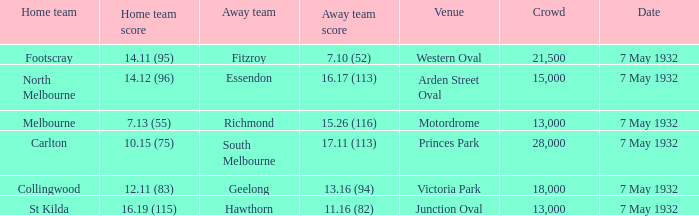What is the total of crowd with Home team score of 14.12 (96)? 15000.0. 